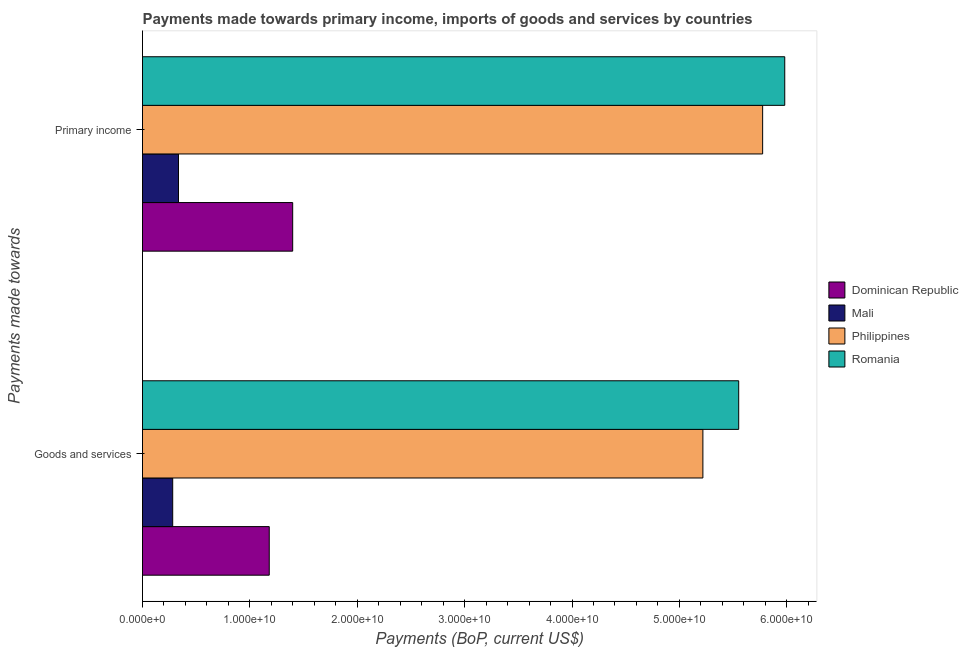How many groups of bars are there?
Provide a short and direct response. 2. How many bars are there on the 1st tick from the bottom?
Ensure brevity in your answer.  4. What is the label of the 1st group of bars from the top?
Provide a succinct answer. Primary income. What is the payments made towards primary income in Philippines?
Provide a succinct answer. 5.78e+1. Across all countries, what is the maximum payments made towards primary income?
Provide a succinct answer. 5.98e+1. Across all countries, what is the minimum payments made towards primary income?
Your answer should be compact. 3.35e+09. In which country was the payments made towards primary income maximum?
Ensure brevity in your answer.  Romania. In which country was the payments made towards primary income minimum?
Offer a very short reply. Mali. What is the total payments made towards goods and services in the graph?
Offer a terse response. 1.22e+11. What is the difference between the payments made towards primary income in Romania and that in Dominican Republic?
Make the answer very short. 4.58e+1. What is the difference between the payments made towards goods and services in Mali and the payments made towards primary income in Philippines?
Your answer should be very brief. -5.49e+1. What is the average payments made towards primary income per country?
Provide a succinct answer. 3.37e+1. What is the difference between the payments made towards goods and services and payments made towards primary income in Mali?
Offer a terse response. -5.39e+08. What is the ratio of the payments made towards goods and services in Philippines to that in Romania?
Offer a very short reply. 0.94. Is the payments made towards goods and services in Romania less than that in Philippines?
Offer a very short reply. No. What does the 3rd bar from the top in Goods and services represents?
Offer a very short reply. Mali. What does the 4th bar from the bottom in Goods and services represents?
Offer a terse response. Romania. Are all the bars in the graph horizontal?
Make the answer very short. Yes. How many countries are there in the graph?
Provide a succinct answer. 4. Are the values on the major ticks of X-axis written in scientific E-notation?
Offer a very short reply. Yes. Where does the legend appear in the graph?
Make the answer very short. Center right. How many legend labels are there?
Provide a succinct answer. 4. What is the title of the graph?
Offer a terse response. Payments made towards primary income, imports of goods and services by countries. Does "French Polynesia" appear as one of the legend labels in the graph?
Offer a very short reply. No. What is the label or title of the X-axis?
Your response must be concise. Payments (BoP, current US$). What is the label or title of the Y-axis?
Offer a very short reply. Payments made towards. What is the Payments (BoP, current US$) of Dominican Republic in Goods and services?
Your answer should be very brief. 1.18e+1. What is the Payments (BoP, current US$) in Mali in Goods and services?
Make the answer very short. 2.81e+09. What is the Payments (BoP, current US$) in Philippines in Goods and services?
Offer a terse response. 5.22e+1. What is the Payments (BoP, current US$) of Romania in Goods and services?
Keep it short and to the point. 5.55e+1. What is the Payments (BoP, current US$) of Dominican Republic in Primary income?
Your response must be concise. 1.40e+1. What is the Payments (BoP, current US$) in Mali in Primary income?
Offer a terse response. 3.35e+09. What is the Payments (BoP, current US$) of Philippines in Primary income?
Provide a short and direct response. 5.78e+1. What is the Payments (BoP, current US$) of Romania in Primary income?
Offer a terse response. 5.98e+1. Across all Payments made towards, what is the maximum Payments (BoP, current US$) in Dominican Republic?
Ensure brevity in your answer.  1.40e+1. Across all Payments made towards, what is the maximum Payments (BoP, current US$) of Mali?
Provide a short and direct response. 3.35e+09. Across all Payments made towards, what is the maximum Payments (BoP, current US$) of Philippines?
Offer a very short reply. 5.78e+1. Across all Payments made towards, what is the maximum Payments (BoP, current US$) in Romania?
Your answer should be compact. 5.98e+1. Across all Payments made towards, what is the minimum Payments (BoP, current US$) of Dominican Republic?
Your answer should be very brief. 1.18e+1. Across all Payments made towards, what is the minimum Payments (BoP, current US$) in Mali?
Keep it short and to the point. 2.81e+09. Across all Payments made towards, what is the minimum Payments (BoP, current US$) in Philippines?
Keep it short and to the point. 5.22e+1. Across all Payments made towards, what is the minimum Payments (BoP, current US$) of Romania?
Ensure brevity in your answer.  5.55e+1. What is the total Payments (BoP, current US$) of Dominican Republic in the graph?
Provide a succinct answer. 2.58e+1. What is the total Payments (BoP, current US$) in Mali in the graph?
Ensure brevity in your answer.  6.16e+09. What is the total Payments (BoP, current US$) of Philippines in the graph?
Ensure brevity in your answer.  1.10e+11. What is the total Payments (BoP, current US$) of Romania in the graph?
Keep it short and to the point. 1.15e+11. What is the difference between the Payments (BoP, current US$) in Dominican Republic in Goods and services and that in Primary income?
Offer a terse response. -2.18e+09. What is the difference between the Payments (BoP, current US$) in Mali in Goods and services and that in Primary income?
Provide a succinct answer. -5.39e+08. What is the difference between the Payments (BoP, current US$) in Philippines in Goods and services and that in Primary income?
Offer a terse response. -5.56e+09. What is the difference between the Payments (BoP, current US$) in Romania in Goods and services and that in Primary income?
Offer a very short reply. -4.29e+09. What is the difference between the Payments (BoP, current US$) in Dominican Republic in Goods and services and the Payments (BoP, current US$) in Mali in Primary income?
Offer a very short reply. 8.45e+09. What is the difference between the Payments (BoP, current US$) of Dominican Republic in Goods and services and the Payments (BoP, current US$) of Philippines in Primary income?
Your answer should be very brief. -4.60e+1. What is the difference between the Payments (BoP, current US$) of Dominican Republic in Goods and services and the Payments (BoP, current US$) of Romania in Primary income?
Offer a terse response. -4.80e+1. What is the difference between the Payments (BoP, current US$) in Mali in Goods and services and the Payments (BoP, current US$) in Philippines in Primary income?
Ensure brevity in your answer.  -5.49e+1. What is the difference between the Payments (BoP, current US$) of Mali in Goods and services and the Payments (BoP, current US$) of Romania in Primary income?
Keep it short and to the point. -5.70e+1. What is the difference between the Payments (BoP, current US$) of Philippines in Goods and services and the Payments (BoP, current US$) of Romania in Primary income?
Provide a short and direct response. -7.62e+09. What is the average Payments (BoP, current US$) of Dominican Republic per Payments made towards?
Your answer should be compact. 1.29e+1. What is the average Payments (BoP, current US$) in Mali per Payments made towards?
Provide a succinct answer. 3.08e+09. What is the average Payments (BoP, current US$) of Philippines per Payments made towards?
Keep it short and to the point. 5.50e+1. What is the average Payments (BoP, current US$) of Romania per Payments made towards?
Offer a terse response. 5.77e+1. What is the difference between the Payments (BoP, current US$) in Dominican Republic and Payments (BoP, current US$) in Mali in Goods and services?
Ensure brevity in your answer.  8.99e+09. What is the difference between the Payments (BoP, current US$) of Dominican Republic and Payments (BoP, current US$) of Philippines in Goods and services?
Make the answer very short. -4.04e+1. What is the difference between the Payments (BoP, current US$) in Dominican Republic and Payments (BoP, current US$) in Romania in Goods and services?
Your response must be concise. -4.37e+1. What is the difference between the Payments (BoP, current US$) in Mali and Payments (BoP, current US$) in Philippines in Goods and services?
Make the answer very short. -4.94e+1. What is the difference between the Payments (BoP, current US$) of Mali and Payments (BoP, current US$) of Romania in Goods and services?
Provide a succinct answer. -5.27e+1. What is the difference between the Payments (BoP, current US$) of Philippines and Payments (BoP, current US$) of Romania in Goods and services?
Keep it short and to the point. -3.33e+09. What is the difference between the Payments (BoP, current US$) of Dominican Republic and Payments (BoP, current US$) of Mali in Primary income?
Your answer should be compact. 1.06e+1. What is the difference between the Payments (BoP, current US$) in Dominican Republic and Payments (BoP, current US$) in Philippines in Primary income?
Your answer should be very brief. -4.38e+1. What is the difference between the Payments (BoP, current US$) of Dominican Republic and Payments (BoP, current US$) of Romania in Primary income?
Your answer should be compact. -4.58e+1. What is the difference between the Payments (BoP, current US$) in Mali and Payments (BoP, current US$) in Philippines in Primary income?
Your response must be concise. -5.44e+1. What is the difference between the Payments (BoP, current US$) of Mali and Payments (BoP, current US$) of Romania in Primary income?
Your response must be concise. -5.65e+1. What is the difference between the Payments (BoP, current US$) of Philippines and Payments (BoP, current US$) of Romania in Primary income?
Your answer should be very brief. -2.06e+09. What is the ratio of the Payments (BoP, current US$) in Dominican Republic in Goods and services to that in Primary income?
Ensure brevity in your answer.  0.84. What is the ratio of the Payments (BoP, current US$) of Mali in Goods and services to that in Primary income?
Offer a very short reply. 0.84. What is the ratio of the Payments (BoP, current US$) of Philippines in Goods and services to that in Primary income?
Ensure brevity in your answer.  0.9. What is the ratio of the Payments (BoP, current US$) of Romania in Goods and services to that in Primary income?
Keep it short and to the point. 0.93. What is the difference between the highest and the second highest Payments (BoP, current US$) in Dominican Republic?
Offer a very short reply. 2.18e+09. What is the difference between the highest and the second highest Payments (BoP, current US$) of Mali?
Ensure brevity in your answer.  5.39e+08. What is the difference between the highest and the second highest Payments (BoP, current US$) in Philippines?
Your answer should be very brief. 5.56e+09. What is the difference between the highest and the second highest Payments (BoP, current US$) of Romania?
Your response must be concise. 4.29e+09. What is the difference between the highest and the lowest Payments (BoP, current US$) in Dominican Republic?
Provide a short and direct response. 2.18e+09. What is the difference between the highest and the lowest Payments (BoP, current US$) of Mali?
Offer a very short reply. 5.39e+08. What is the difference between the highest and the lowest Payments (BoP, current US$) of Philippines?
Keep it short and to the point. 5.56e+09. What is the difference between the highest and the lowest Payments (BoP, current US$) in Romania?
Keep it short and to the point. 4.29e+09. 